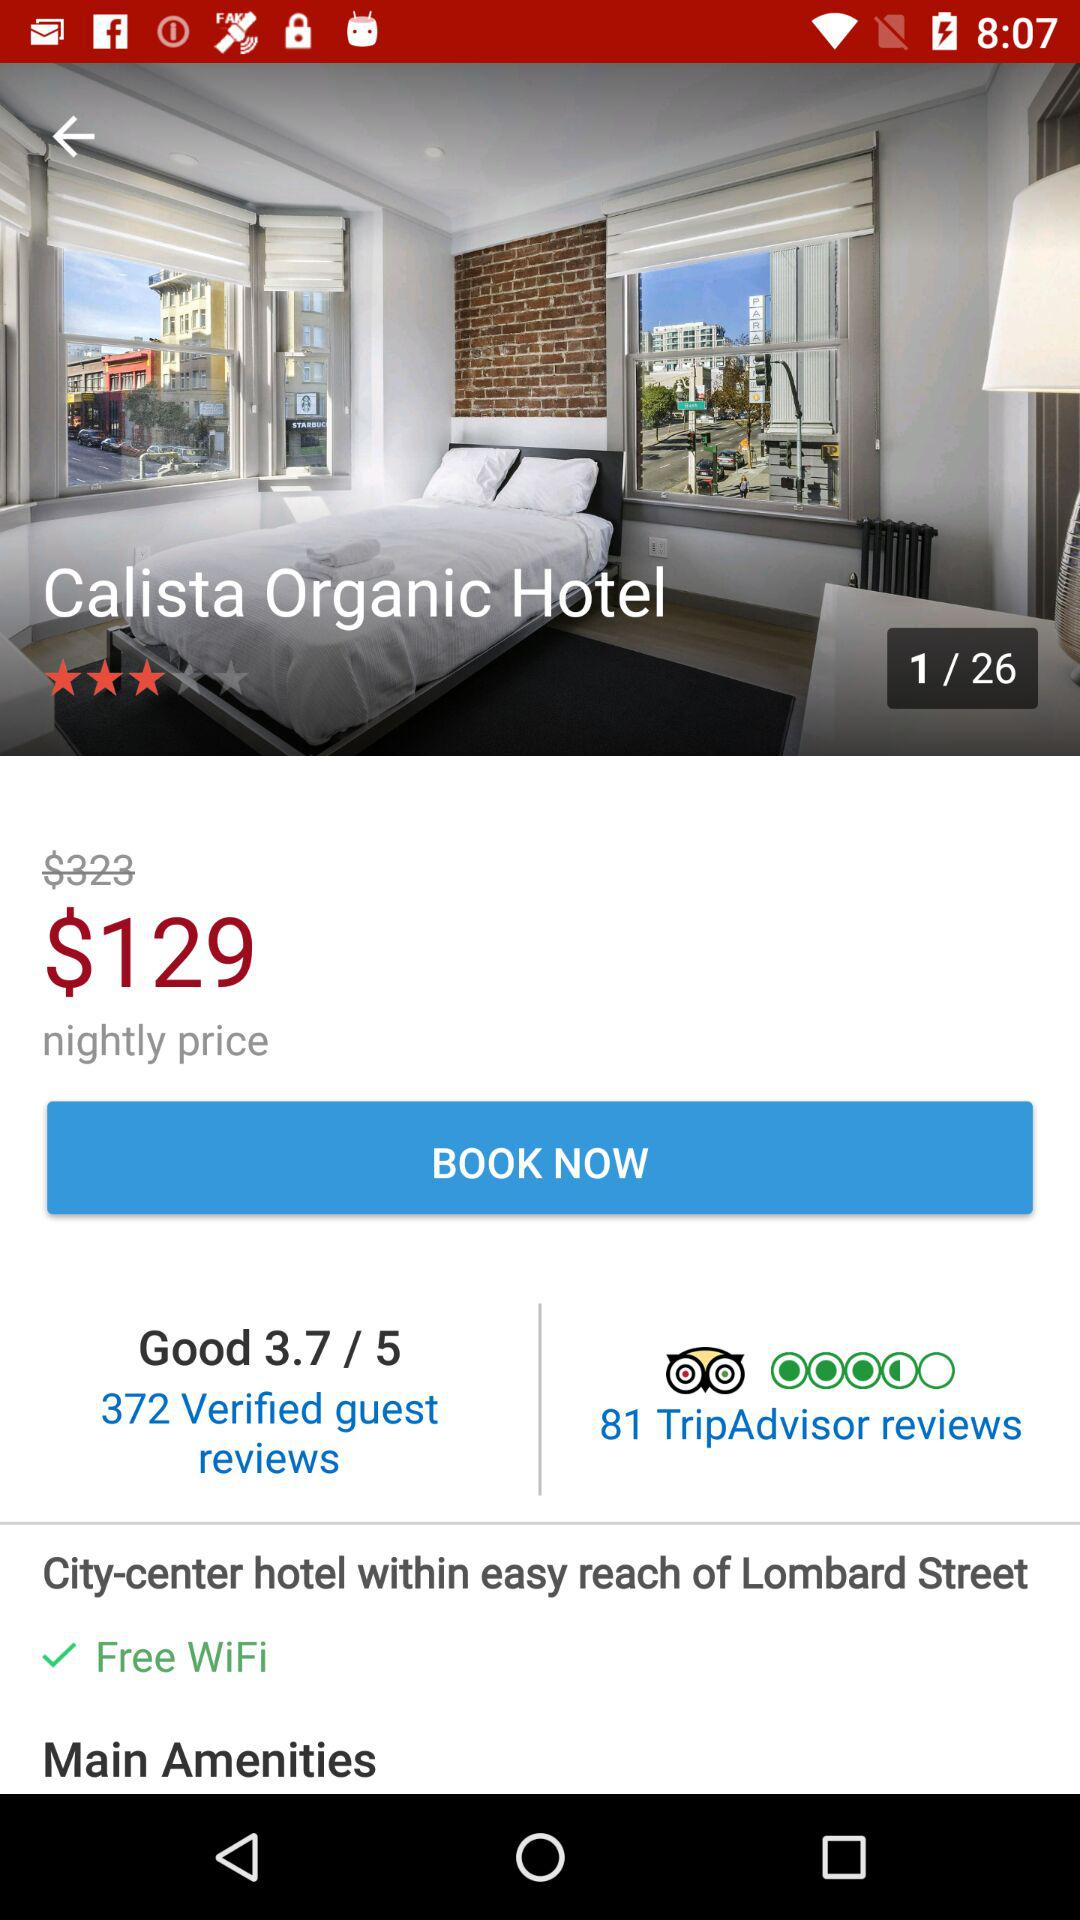What is the number of verified guest reviews? The number of verified guest reviews is 372. 